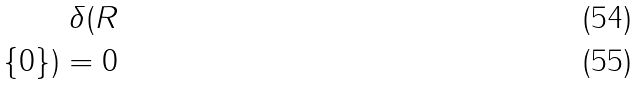<formula> <loc_0><loc_0><loc_500><loc_500>\delta ( R \\ \{ 0 \} ) = 0</formula> 